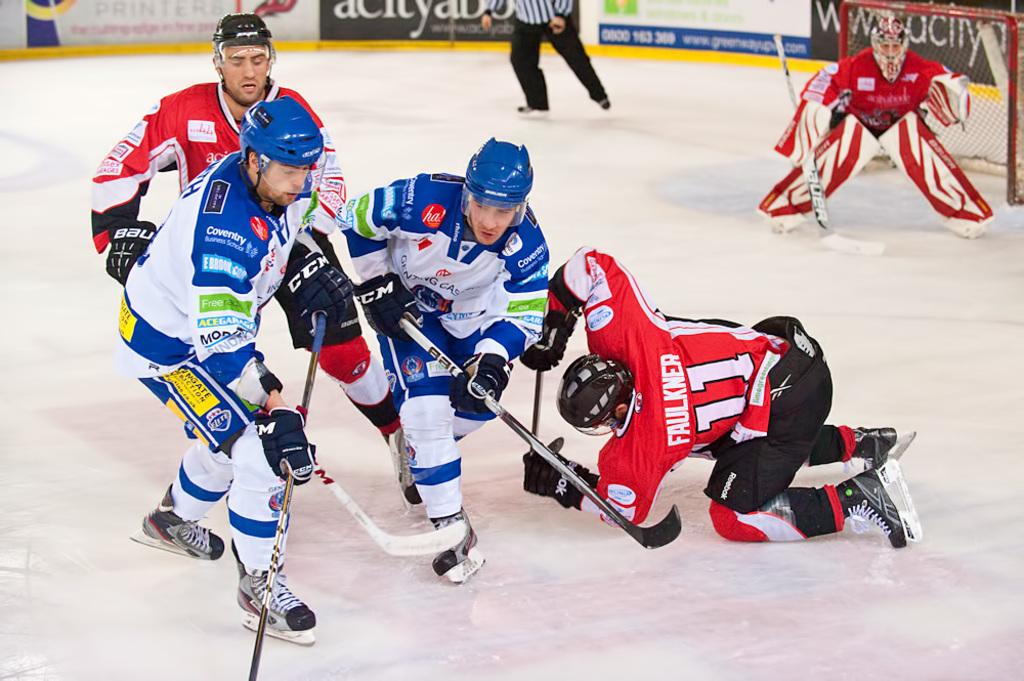What number is the player who is on his knees?
Ensure brevity in your answer.  11. 